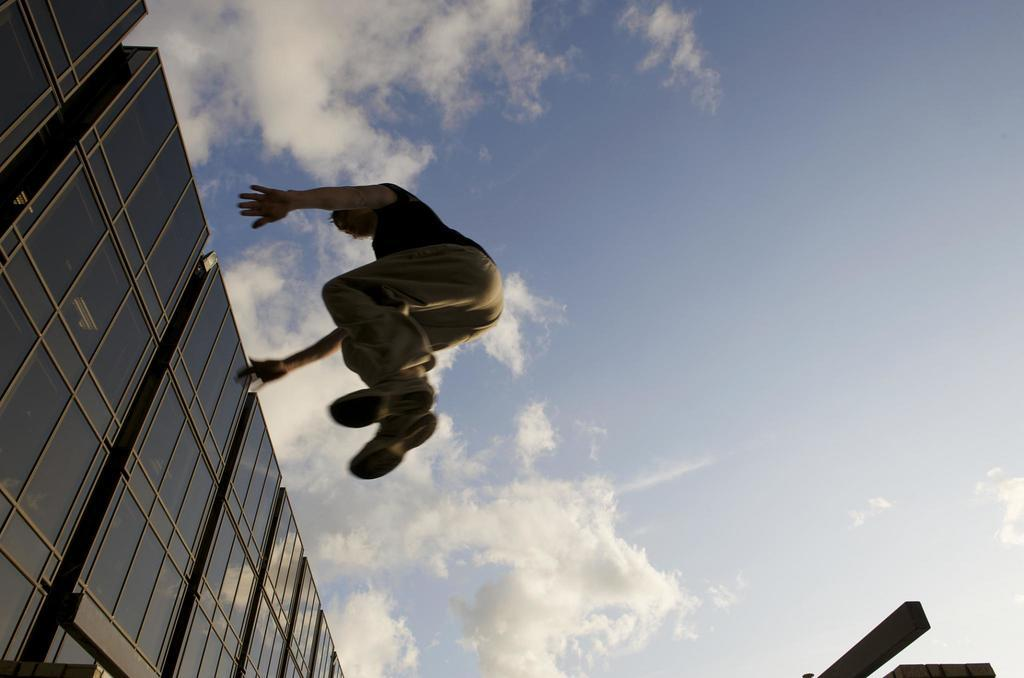What is the person in the image doing? There is a person in the air in the image, which suggests they might be flying or jumping. What can be seen behind the person? There is a wall visible in the image. What is visible in the background of the image? The sky is visible in the background, and clouds are present. What type of wound can be seen on the person's knee in the image? There is no wound visible on the person's knee in the image, as the person is in the air and their knees are not visible. 